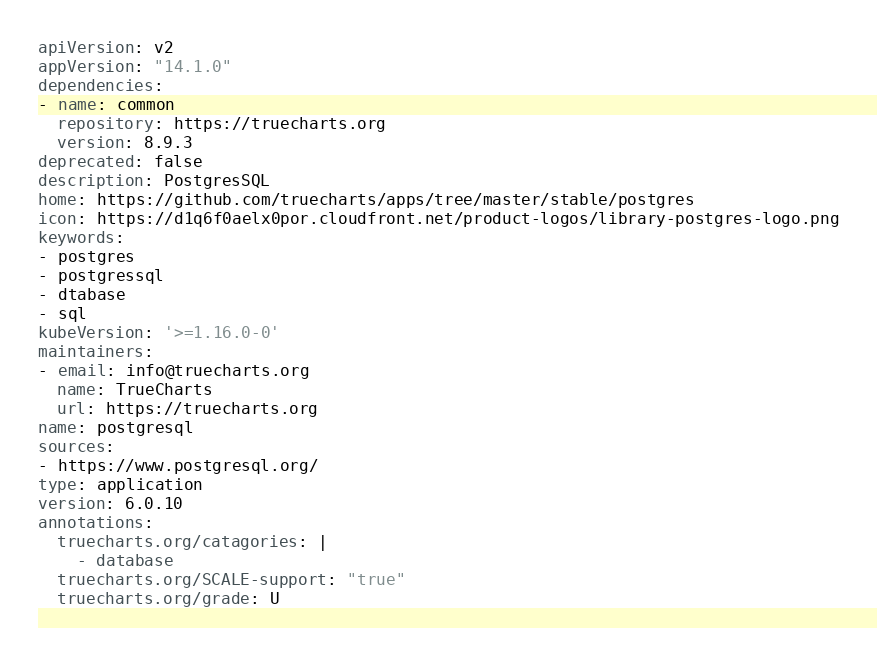Convert code to text. <code><loc_0><loc_0><loc_500><loc_500><_YAML_>apiVersion: v2
appVersion: "14.1.0"
dependencies:
- name: common
  repository: https://truecharts.org
  version: 8.9.3
deprecated: false
description: PostgresSQL
home: https://github.com/truecharts/apps/tree/master/stable/postgres
icon: https://d1q6f0aelx0por.cloudfront.net/product-logos/library-postgres-logo.png
keywords:
- postgres
- postgressql
- dtabase
- sql
kubeVersion: '>=1.16.0-0'
maintainers:
- email: info@truecharts.org
  name: TrueCharts
  url: https://truecharts.org
name: postgresql
sources:
- https://www.postgresql.org/
type: application
version: 6.0.10
annotations:
  truecharts.org/catagories: |
    - database
  truecharts.org/SCALE-support: "true"
  truecharts.org/grade: U
</code> 